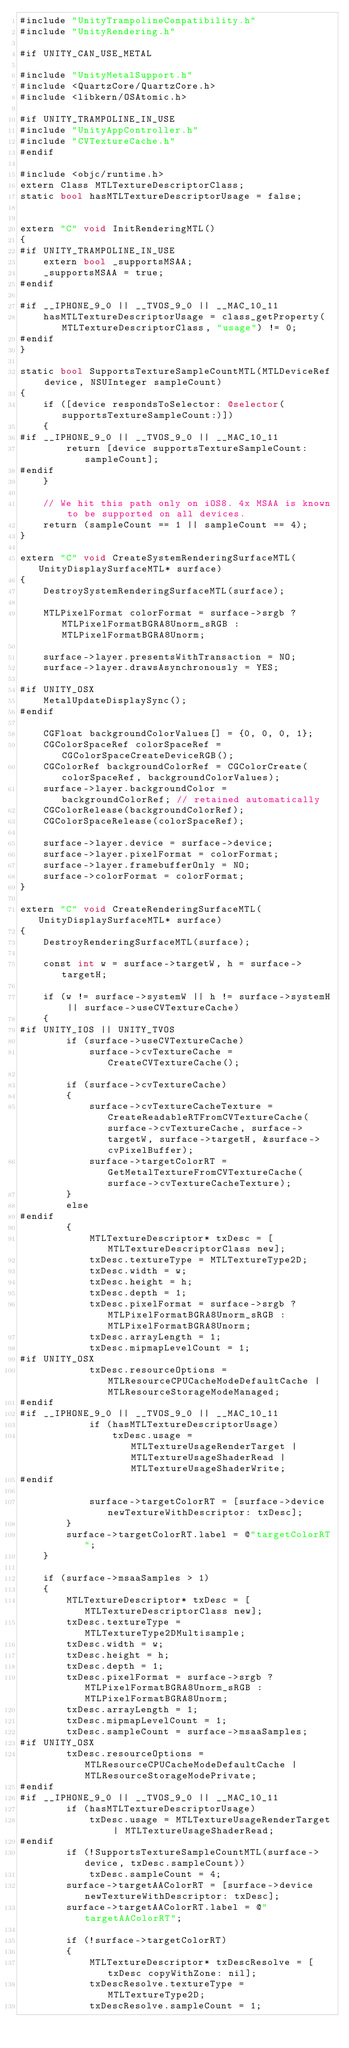Convert code to text. <code><loc_0><loc_0><loc_500><loc_500><_ObjectiveC_>#include "UnityTrampolineCompatibility.h"
#include "UnityRendering.h"

#if UNITY_CAN_USE_METAL

#include "UnityMetalSupport.h"
#include <QuartzCore/QuartzCore.h>
#include <libkern/OSAtomic.h>

#if UNITY_TRAMPOLINE_IN_USE
#include "UnityAppController.h"
#include "CVTextureCache.h"
#endif

#include <objc/runtime.h>
extern Class MTLTextureDescriptorClass;
static bool hasMTLTextureDescriptorUsage = false;


extern "C" void InitRenderingMTL()
{
#if UNITY_TRAMPOLINE_IN_USE
    extern bool _supportsMSAA;
    _supportsMSAA = true;
#endif

#if __IPHONE_9_0 || __TVOS_9_0 || __MAC_10_11
    hasMTLTextureDescriptorUsage = class_getProperty(MTLTextureDescriptorClass, "usage") != 0;
#endif
}

static bool SupportsTextureSampleCountMTL(MTLDeviceRef device, NSUInteger sampleCount)
{
    if ([device respondsToSelector: @selector(supportsTextureSampleCount:)])
    {
#if __IPHONE_9_0 || __TVOS_9_0 || __MAC_10_11
        return [device supportsTextureSampleCount: sampleCount];
#endif
    }

    // We hit this path only on iOS8. 4x MSAA is known to be supported on all devices.
    return (sampleCount == 1 || sampleCount == 4);
}

extern "C" void CreateSystemRenderingSurfaceMTL(UnityDisplaySurfaceMTL* surface)
{
    DestroySystemRenderingSurfaceMTL(surface);

    MTLPixelFormat colorFormat = surface->srgb ? MTLPixelFormatBGRA8Unorm_sRGB : MTLPixelFormatBGRA8Unorm;

    surface->layer.presentsWithTransaction = NO;
    surface->layer.drawsAsynchronously = YES;

#if UNITY_OSX
    MetalUpdateDisplaySync();
#endif

    CGFloat backgroundColorValues[] = {0, 0, 0, 1};
    CGColorSpaceRef colorSpaceRef = CGColorSpaceCreateDeviceRGB();
    CGColorRef backgroundColorRef = CGColorCreate(colorSpaceRef, backgroundColorValues);
    surface->layer.backgroundColor = backgroundColorRef; // retained automatically
    CGColorRelease(backgroundColorRef);
    CGColorSpaceRelease(colorSpaceRef);

    surface->layer.device = surface->device;
    surface->layer.pixelFormat = colorFormat;
    surface->layer.framebufferOnly = NO;
    surface->colorFormat = colorFormat;
}

extern "C" void CreateRenderingSurfaceMTL(UnityDisplaySurfaceMTL* surface)
{
    DestroyRenderingSurfaceMTL(surface);

    const int w = surface->targetW, h = surface->targetH;

    if (w != surface->systemW || h != surface->systemH || surface->useCVTextureCache)
    {
#if UNITY_IOS || UNITY_TVOS
        if (surface->useCVTextureCache)
            surface->cvTextureCache = CreateCVTextureCache();

        if (surface->cvTextureCache)
        {
            surface->cvTextureCacheTexture = CreateReadableRTFromCVTextureCache(surface->cvTextureCache, surface->targetW, surface->targetH, &surface->cvPixelBuffer);
            surface->targetColorRT = GetMetalTextureFromCVTextureCache(surface->cvTextureCacheTexture);
        }
        else
#endif
        {
            MTLTextureDescriptor* txDesc = [MTLTextureDescriptorClass new];
            txDesc.textureType = MTLTextureType2D;
            txDesc.width = w;
            txDesc.height = h;
            txDesc.depth = 1;
            txDesc.pixelFormat = surface->srgb ? MTLPixelFormatBGRA8Unorm_sRGB : MTLPixelFormatBGRA8Unorm;
            txDesc.arrayLength = 1;
            txDesc.mipmapLevelCount = 1;
#if UNITY_OSX
            txDesc.resourceOptions = MTLResourceCPUCacheModeDefaultCache | MTLResourceStorageModeManaged;
#endif
#if __IPHONE_9_0 || __TVOS_9_0 || __MAC_10_11
            if (hasMTLTextureDescriptorUsage)
                txDesc.usage = MTLTextureUsageRenderTarget | MTLTextureUsageShaderRead | MTLTextureUsageShaderWrite;
#endif

            surface->targetColorRT = [surface->device newTextureWithDescriptor: txDesc];
        }
        surface->targetColorRT.label = @"targetColorRT";
    }

    if (surface->msaaSamples > 1)
    {
        MTLTextureDescriptor* txDesc = [MTLTextureDescriptorClass new];
        txDesc.textureType = MTLTextureType2DMultisample;
        txDesc.width = w;
        txDesc.height = h;
        txDesc.depth = 1;
        txDesc.pixelFormat = surface->srgb ? MTLPixelFormatBGRA8Unorm_sRGB : MTLPixelFormatBGRA8Unorm;
        txDesc.arrayLength = 1;
        txDesc.mipmapLevelCount = 1;
        txDesc.sampleCount = surface->msaaSamples;
#if UNITY_OSX
        txDesc.resourceOptions = MTLResourceCPUCacheModeDefaultCache | MTLResourceStorageModePrivate;
#endif
#if __IPHONE_9_0 || __TVOS_9_0 || __MAC_10_11
        if (hasMTLTextureDescriptorUsage)
            txDesc.usage = MTLTextureUsageRenderTarget | MTLTextureUsageShaderRead;
#endif
        if (!SupportsTextureSampleCountMTL(surface->device, txDesc.sampleCount))
            txDesc.sampleCount = 4;
        surface->targetAAColorRT = [surface->device newTextureWithDescriptor: txDesc];
        surface->targetAAColorRT.label = @"targetAAColorRT";

        if (!surface->targetColorRT)
        {
            MTLTextureDescriptor* txDescResolve = [txDesc copyWithZone: nil];
            txDescResolve.textureType = MTLTextureType2D;
            txDescResolve.sampleCount = 1;</code> 